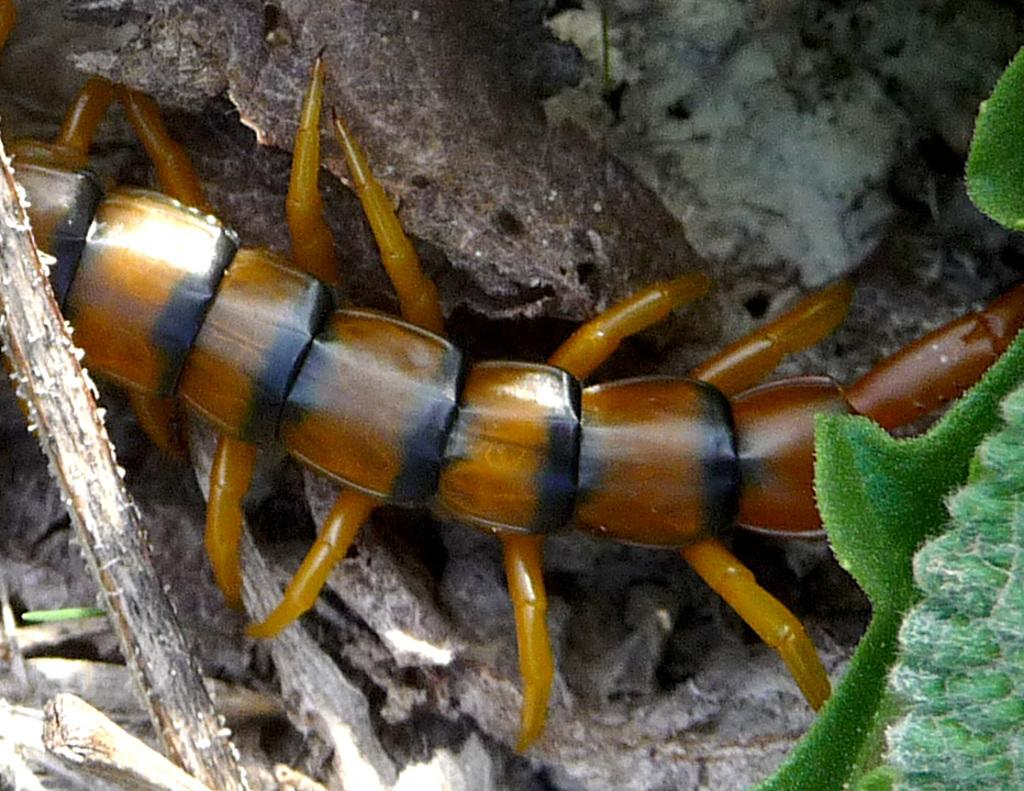What is on the rock in the image? There is an insect on a rock in the image. What can be seen towards the right side of the image? There is a leaf towards the right side of the image. What type of soup is being served in the image? There is no soup present in the image; it features an insect on a rock and a leaf. What is the insect wishing for in the image? Insects do not have the ability to make wishes, and there is no indication of a wish in the image. 